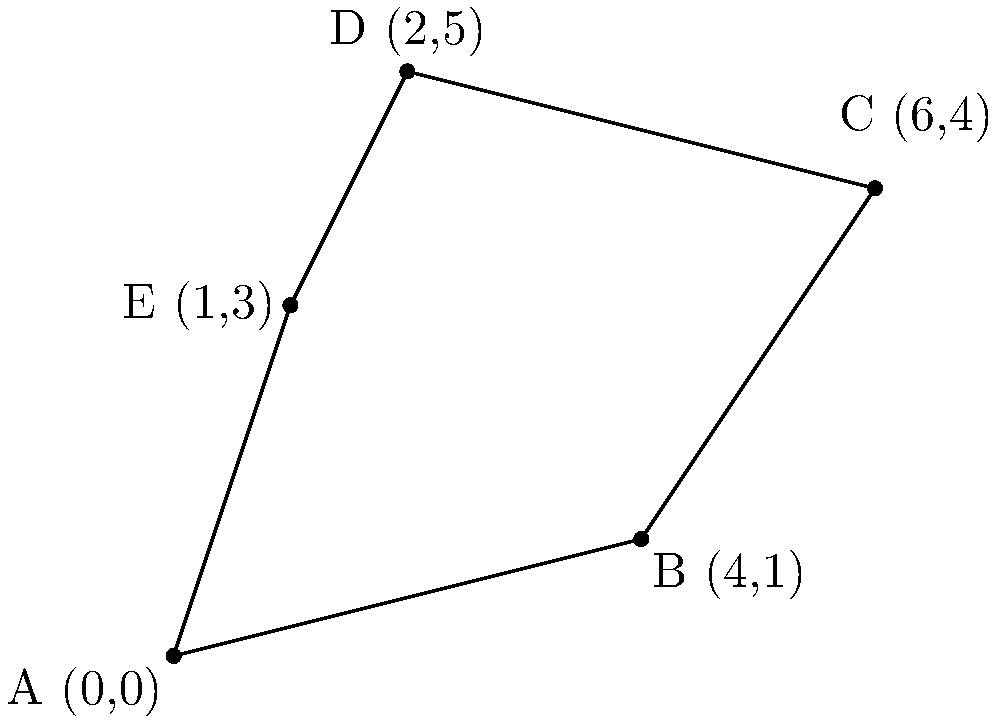On a map of Istanbul, five Ottoman-era buildings are plotted on a coordinate grid. The locations of these buildings form a polygon ABCDE. Given the coordinates A(0,0), B(4,1), C(6,4), D(2,5), and E(1,3), calculate the area of the polygon formed by connecting these points. Round your answer to the nearest whole number. To find the area of the irregular polygon ABCDE, we can use the Shoelace formula (also known as the surveyor's formula). The steps are as follows:

1) The Shoelace formula for a polygon with vertices $(x_1, y_1), (x_2, y_2), ..., (x_n, y_n)$ is:

   Area = $\frac{1}{2}|((x_1y_2 + x_2y_3 + ... + x_ny_1) - (y_1x_2 + y_2x_3 + ... + y_nx_1))|$

2) Substituting our coordinates:
   A(0,0), B(4,1), C(6,4), D(2,5), E(1,3)

3) Applying the formula:

   Area = $\frac{1}{2}|((0 \cdot 1 + 4 \cdot 4 + 6 \cdot 5 + 2 \cdot 3 + 1 \cdot 0) - (0 \cdot 4 + 1 \cdot 6 + 4 \cdot 2 + 5 \cdot 1 + 3 \cdot 0))|$

4) Simplifying:

   Area = $\frac{1}{2}|((0 + 16 + 30 + 6 + 0) - (0 + 6 + 8 + 5 + 0))|$
   
   Area = $\frac{1}{2}|(52 - 19)|$
   
   Area = $\frac{1}{2}(33)$
   
   Area = 16.5

5) Rounding to the nearest whole number:

   Area ≈ 17
Answer: 17 square units 